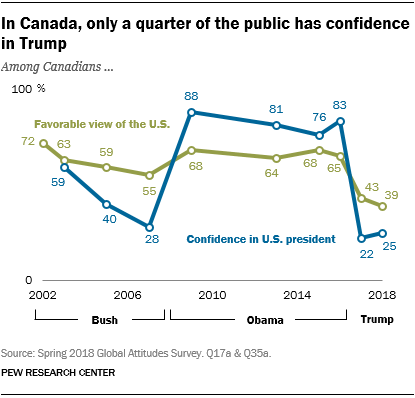Highlight a few significant elements in this photo. The sum of the smallest values of the blue graph is greater than the smallest value of the green graph. 